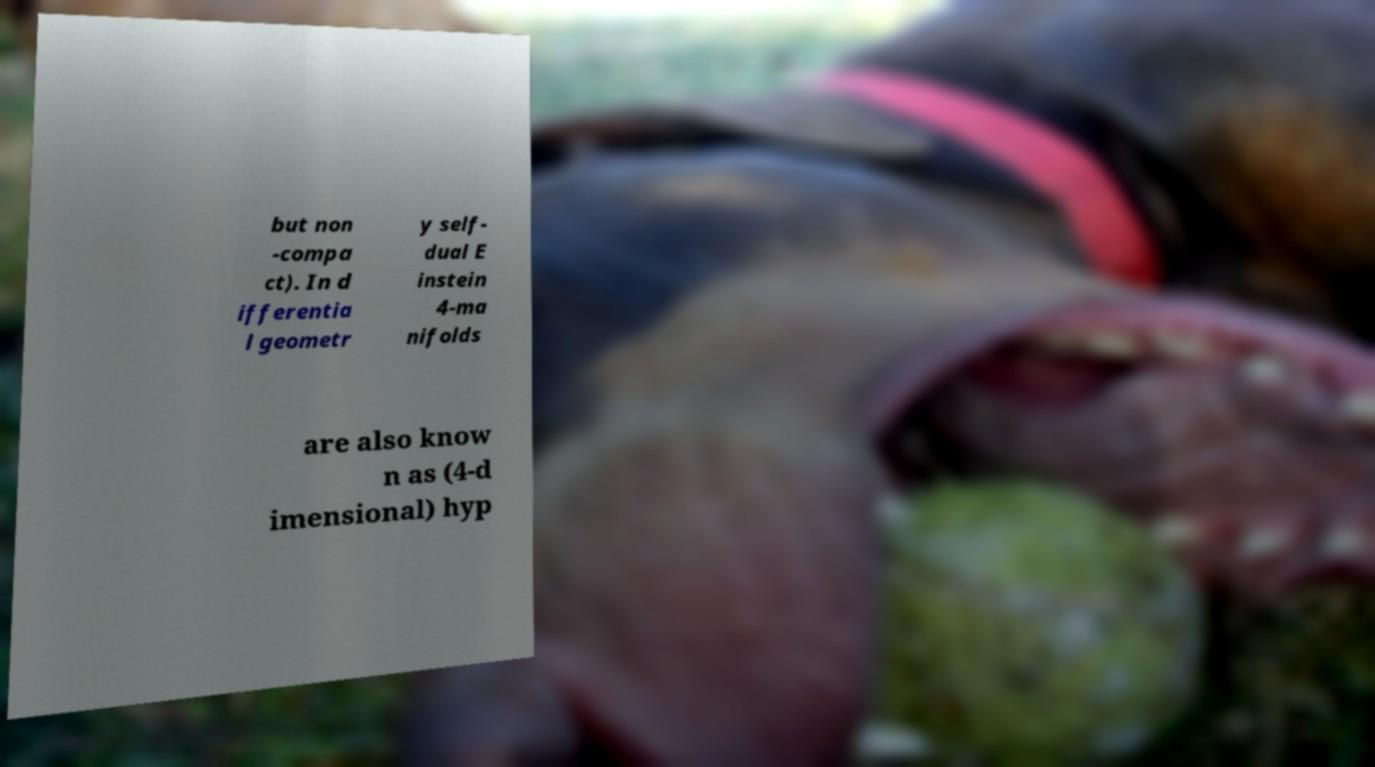For documentation purposes, I need the text within this image transcribed. Could you provide that? but non -compa ct). In d ifferentia l geometr y self- dual E instein 4-ma nifolds are also know n as (4-d imensional) hyp 